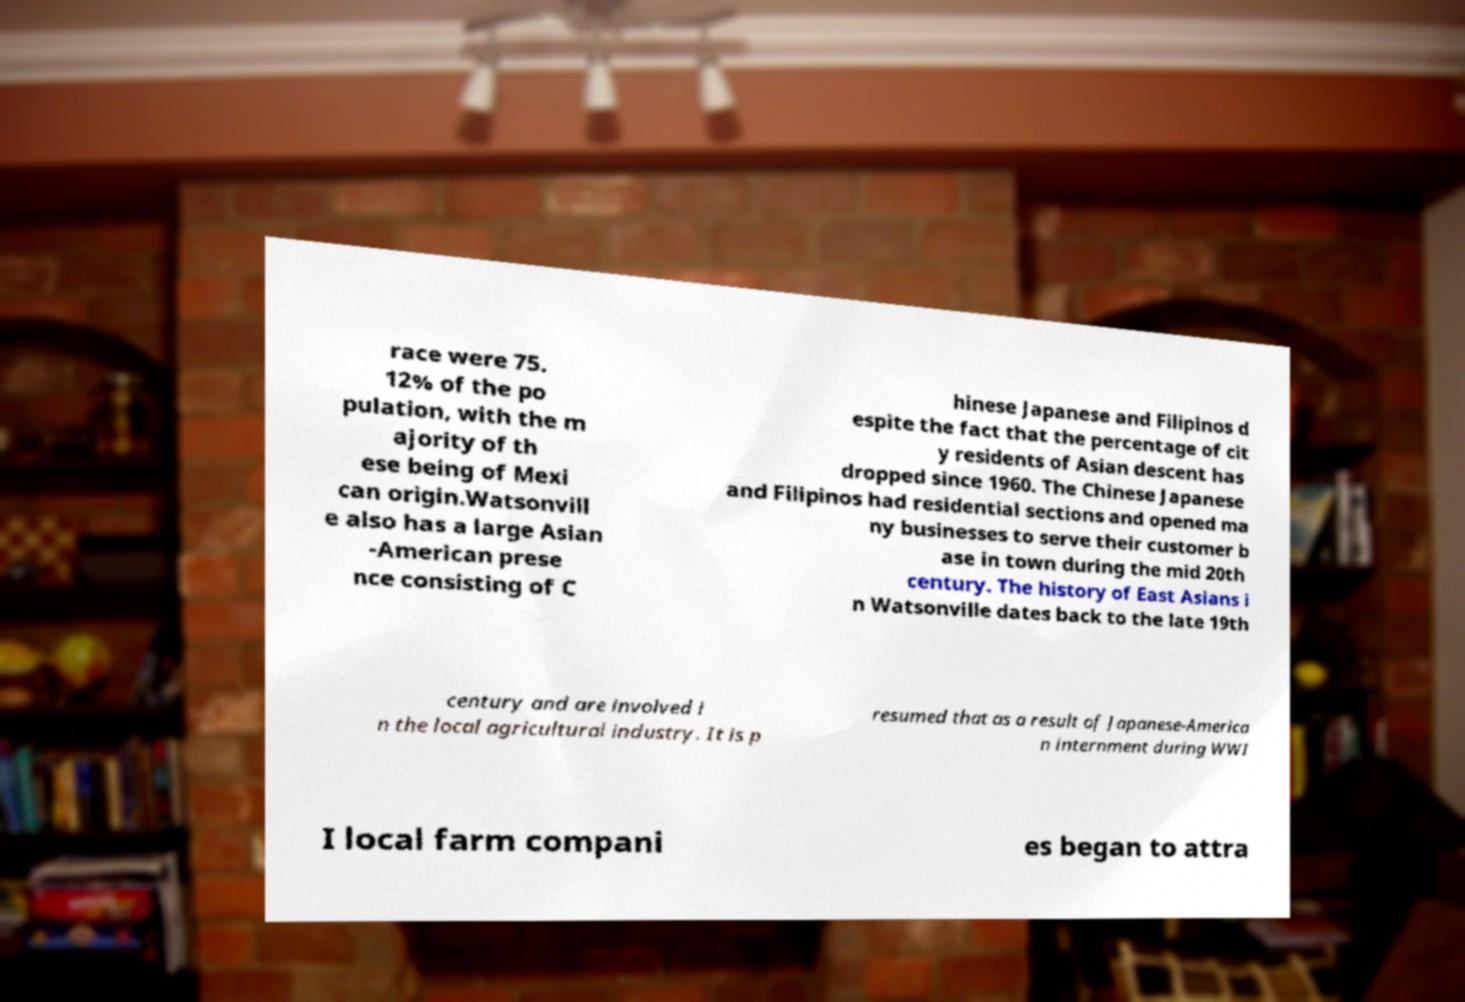I need the written content from this picture converted into text. Can you do that? race were 75. 12% of the po pulation, with the m ajority of th ese being of Mexi can origin.Watsonvill e also has a large Asian -American prese nce consisting of C hinese Japanese and Filipinos d espite the fact that the percentage of cit y residents of Asian descent has dropped since 1960. The Chinese Japanese and Filipinos had residential sections and opened ma ny businesses to serve their customer b ase in town during the mid 20th century. The history of East Asians i n Watsonville dates back to the late 19th century and are involved i n the local agricultural industry. It is p resumed that as a result of Japanese-America n internment during WWI I local farm compani es began to attra 